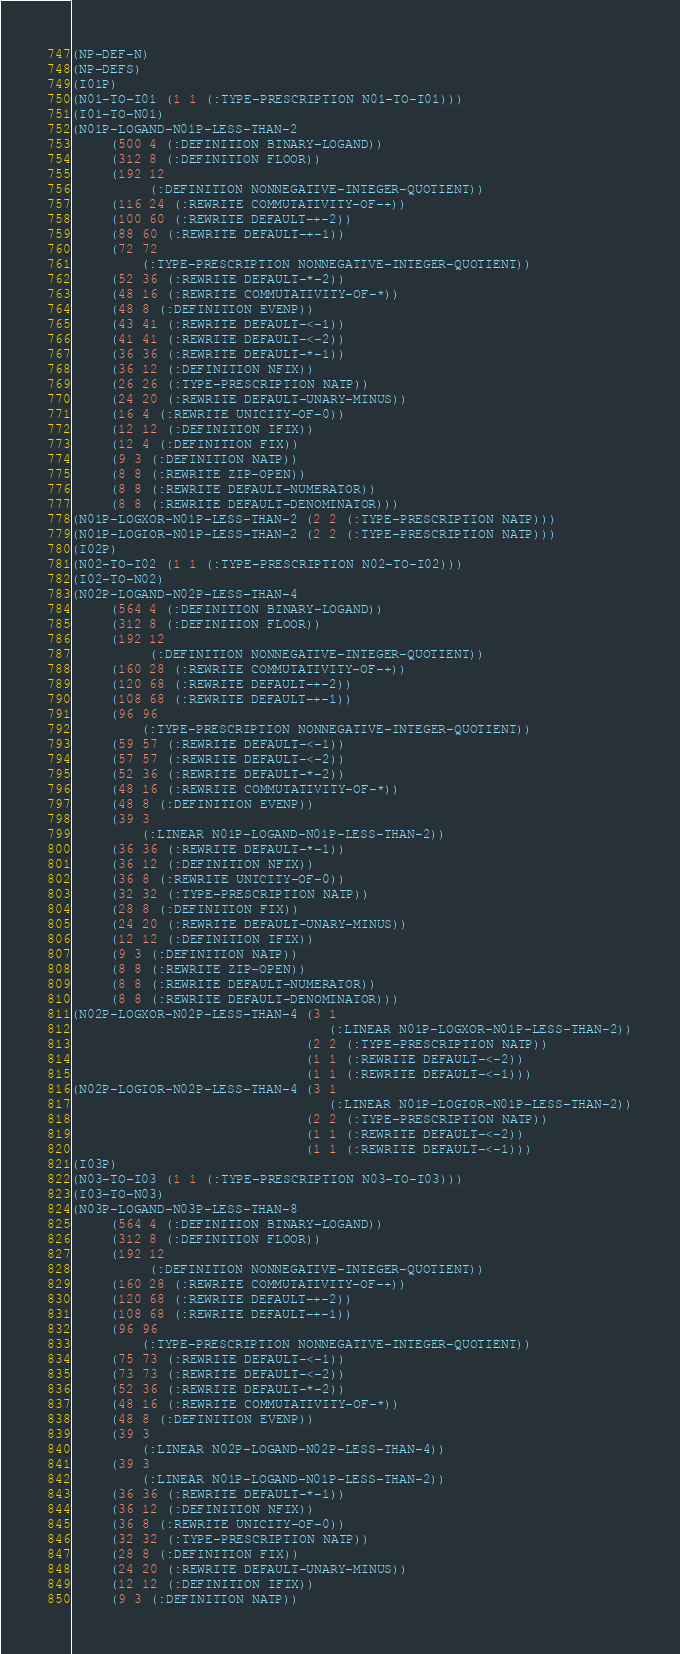Convert code to text. <code><loc_0><loc_0><loc_500><loc_500><_Lisp_>(NP-DEF-N)
(NP-DEFS)
(I01P)
(N01-TO-I01 (1 1 (:TYPE-PRESCRIPTION N01-TO-I01)))
(I01-TO-N01)
(N01P-LOGAND-N01P-LESS-THAN-2
     (500 4 (:DEFINITION BINARY-LOGAND))
     (312 8 (:DEFINITION FLOOR))
     (192 12
          (:DEFINITION NONNEGATIVE-INTEGER-QUOTIENT))
     (116 24 (:REWRITE COMMUTATIVITY-OF-+))
     (100 60 (:REWRITE DEFAULT-+-2))
     (88 60 (:REWRITE DEFAULT-+-1))
     (72 72
         (:TYPE-PRESCRIPTION NONNEGATIVE-INTEGER-QUOTIENT))
     (52 36 (:REWRITE DEFAULT-*-2))
     (48 16 (:REWRITE COMMUTATIVITY-OF-*))
     (48 8 (:DEFINITION EVENP))
     (43 41 (:REWRITE DEFAULT-<-1))
     (41 41 (:REWRITE DEFAULT-<-2))
     (36 36 (:REWRITE DEFAULT-*-1))
     (36 12 (:DEFINITION NFIX))
     (26 26 (:TYPE-PRESCRIPTION NATP))
     (24 20 (:REWRITE DEFAULT-UNARY-MINUS))
     (16 4 (:REWRITE UNICITY-OF-0))
     (12 12 (:DEFINITION IFIX))
     (12 4 (:DEFINITION FIX))
     (9 3 (:DEFINITION NATP))
     (8 8 (:REWRITE ZIP-OPEN))
     (8 8 (:REWRITE DEFAULT-NUMERATOR))
     (8 8 (:REWRITE DEFAULT-DENOMINATOR)))
(N01P-LOGXOR-N01P-LESS-THAN-2 (2 2 (:TYPE-PRESCRIPTION NATP)))
(N01P-LOGIOR-N01P-LESS-THAN-2 (2 2 (:TYPE-PRESCRIPTION NATP)))
(I02P)
(N02-TO-I02 (1 1 (:TYPE-PRESCRIPTION N02-TO-I02)))
(I02-TO-N02)
(N02P-LOGAND-N02P-LESS-THAN-4
     (564 4 (:DEFINITION BINARY-LOGAND))
     (312 8 (:DEFINITION FLOOR))
     (192 12
          (:DEFINITION NONNEGATIVE-INTEGER-QUOTIENT))
     (160 28 (:REWRITE COMMUTATIVITY-OF-+))
     (120 68 (:REWRITE DEFAULT-+-2))
     (108 68 (:REWRITE DEFAULT-+-1))
     (96 96
         (:TYPE-PRESCRIPTION NONNEGATIVE-INTEGER-QUOTIENT))
     (59 57 (:REWRITE DEFAULT-<-1))
     (57 57 (:REWRITE DEFAULT-<-2))
     (52 36 (:REWRITE DEFAULT-*-2))
     (48 16 (:REWRITE COMMUTATIVITY-OF-*))
     (48 8 (:DEFINITION EVENP))
     (39 3
         (:LINEAR N01P-LOGAND-N01P-LESS-THAN-2))
     (36 36 (:REWRITE DEFAULT-*-1))
     (36 12 (:DEFINITION NFIX))
     (36 8 (:REWRITE UNICITY-OF-0))
     (32 32 (:TYPE-PRESCRIPTION NATP))
     (28 8 (:DEFINITION FIX))
     (24 20 (:REWRITE DEFAULT-UNARY-MINUS))
     (12 12 (:DEFINITION IFIX))
     (9 3 (:DEFINITION NATP))
     (8 8 (:REWRITE ZIP-OPEN))
     (8 8 (:REWRITE DEFAULT-NUMERATOR))
     (8 8 (:REWRITE DEFAULT-DENOMINATOR)))
(N02P-LOGXOR-N02P-LESS-THAN-4 (3 1
                                 (:LINEAR N01P-LOGXOR-N01P-LESS-THAN-2))
                              (2 2 (:TYPE-PRESCRIPTION NATP))
                              (1 1 (:REWRITE DEFAULT-<-2))
                              (1 1 (:REWRITE DEFAULT-<-1)))
(N02P-LOGIOR-N02P-LESS-THAN-4 (3 1
                                 (:LINEAR N01P-LOGIOR-N01P-LESS-THAN-2))
                              (2 2 (:TYPE-PRESCRIPTION NATP))
                              (1 1 (:REWRITE DEFAULT-<-2))
                              (1 1 (:REWRITE DEFAULT-<-1)))
(I03P)
(N03-TO-I03 (1 1 (:TYPE-PRESCRIPTION N03-TO-I03)))
(I03-TO-N03)
(N03P-LOGAND-N03P-LESS-THAN-8
     (564 4 (:DEFINITION BINARY-LOGAND))
     (312 8 (:DEFINITION FLOOR))
     (192 12
          (:DEFINITION NONNEGATIVE-INTEGER-QUOTIENT))
     (160 28 (:REWRITE COMMUTATIVITY-OF-+))
     (120 68 (:REWRITE DEFAULT-+-2))
     (108 68 (:REWRITE DEFAULT-+-1))
     (96 96
         (:TYPE-PRESCRIPTION NONNEGATIVE-INTEGER-QUOTIENT))
     (75 73 (:REWRITE DEFAULT-<-1))
     (73 73 (:REWRITE DEFAULT-<-2))
     (52 36 (:REWRITE DEFAULT-*-2))
     (48 16 (:REWRITE COMMUTATIVITY-OF-*))
     (48 8 (:DEFINITION EVENP))
     (39 3
         (:LINEAR N02P-LOGAND-N02P-LESS-THAN-4))
     (39 3
         (:LINEAR N01P-LOGAND-N01P-LESS-THAN-2))
     (36 36 (:REWRITE DEFAULT-*-1))
     (36 12 (:DEFINITION NFIX))
     (36 8 (:REWRITE UNICITY-OF-0))
     (32 32 (:TYPE-PRESCRIPTION NATP))
     (28 8 (:DEFINITION FIX))
     (24 20 (:REWRITE DEFAULT-UNARY-MINUS))
     (12 12 (:DEFINITION IFIX))
     (9 3 (:DEFINITION NATP))</code> 